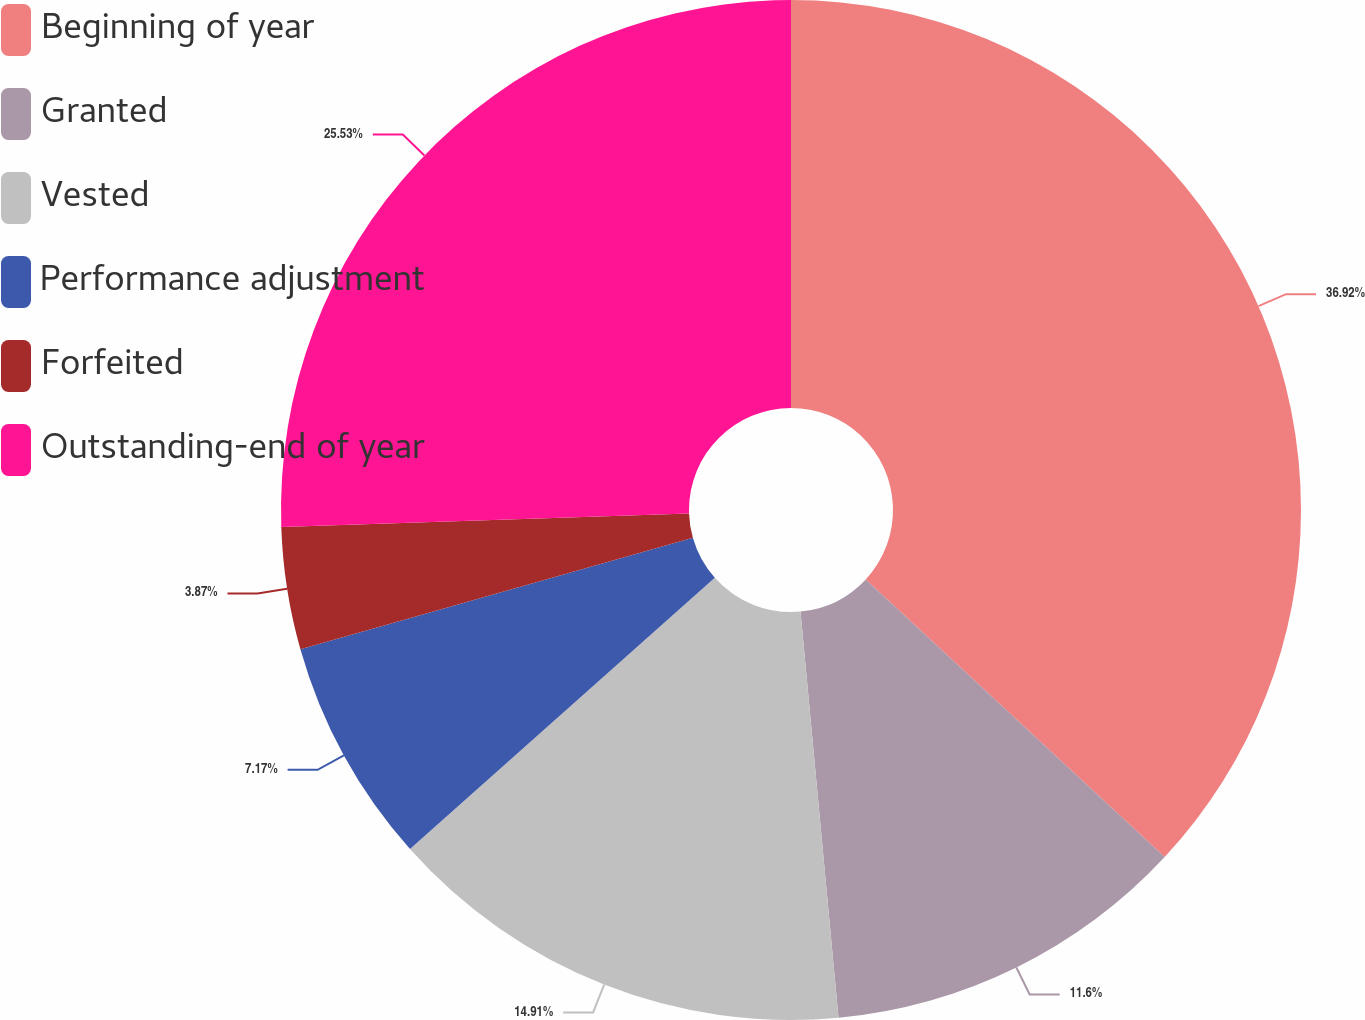<chart> <loc_0><loc_0><loc_500><loc_500><pie_chart><fcel>Beginning of year<fcel>Granted<fcel>Vested<fcel>Performance adjustment<fcel>Forfeited<fcel>Outstanding-end of year<nl><fcel>36.91%<fcel>11.6%<fcel>14.91%<fcel>7.17%<fcel>3.87%<fcel>25.53%<nl></chart> 